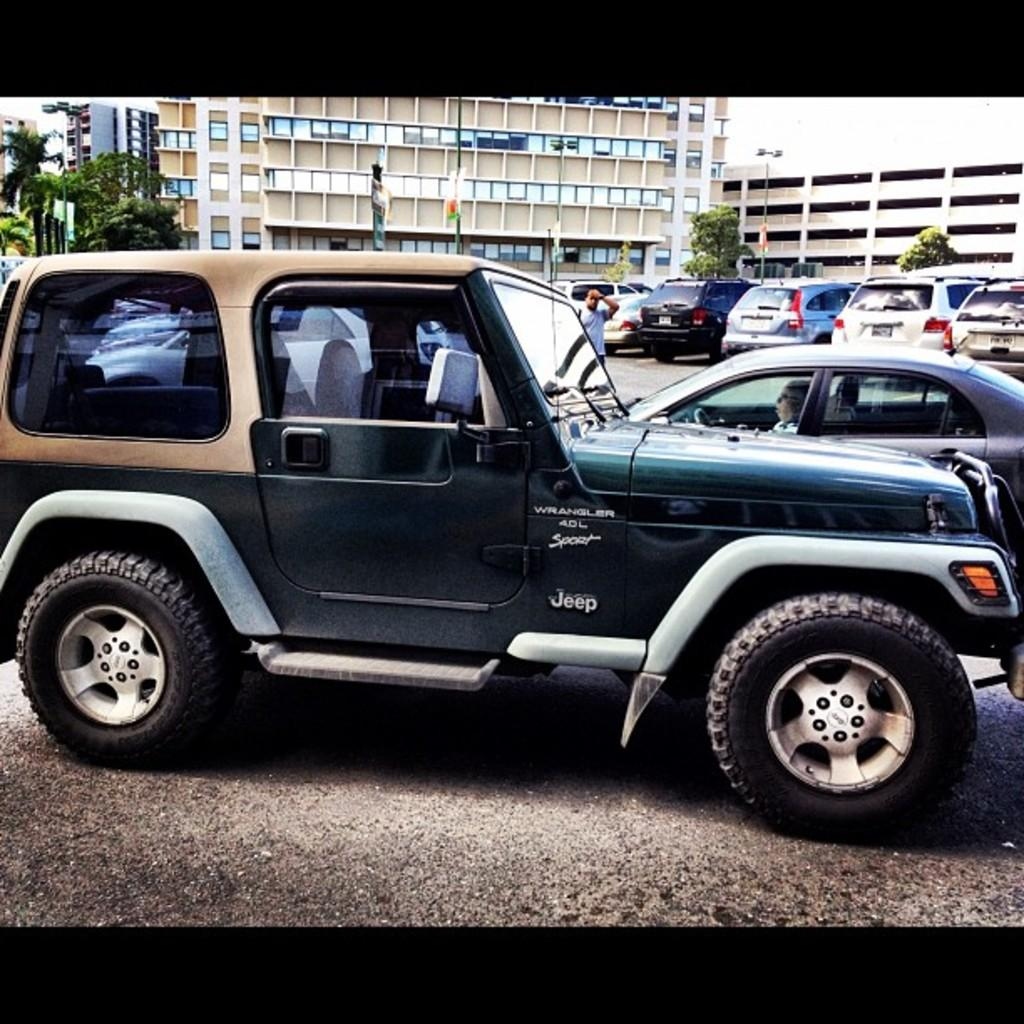What can be seen on the road in the image? There are vehicles on the road in the image. Are there any people on the road in the image? Yes, there is a person on the road in the image. What is visible behind the vehicles in the image? There are poles, trees, and buildings visible behind the vehicles in the image. How many books can be seen in the image? There are no books present in the image. Is the person's aunt visible in the image? There is no mention of an aunt in the image, and no such person is visible. 